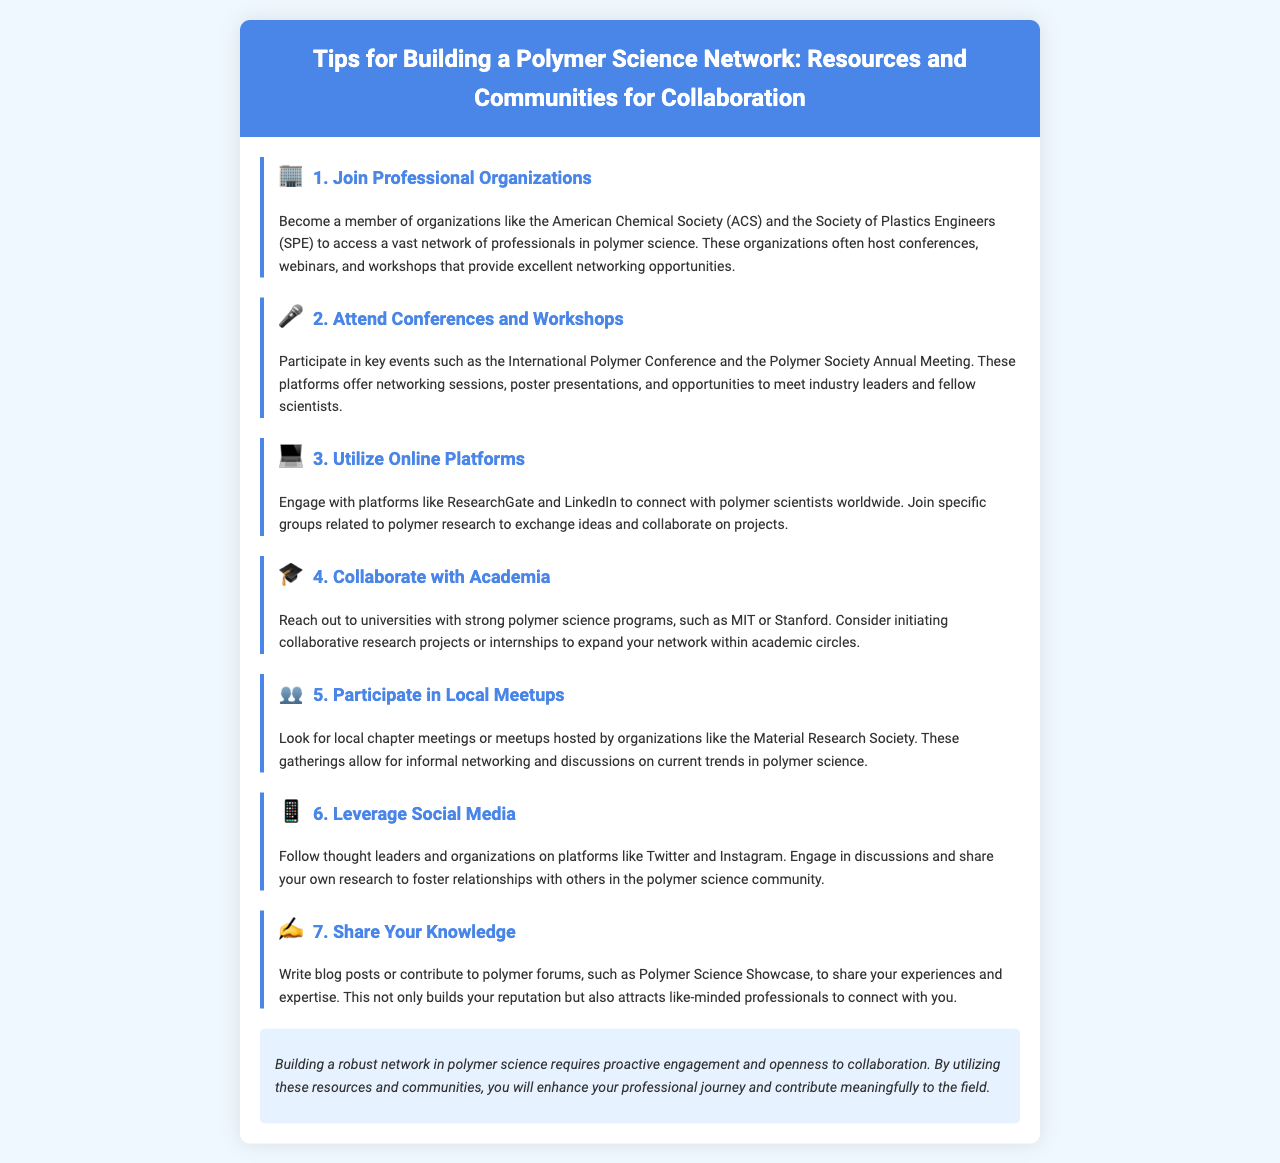What is the title of the brochure? The title is stated at the top of the document, summarizing the focus on networking in polymer science.
Answer: Tips for Building a Polymer Science Network: Resources and Communities for Collaboration Which organization is mentioned for membership? The document lists specific professional organizations that individuals can join for networking opportunities in polymer science.
Answer: American Chemical Society (ACS) How many tips are provided in the brochure? The brochure includes a numbered list of tips to build a polymer science network, which can be counted directly from the sections.
Answer: 7 What type of events are emphasized for networking? The document outlines specific events where networking occurs, indicating the importance of participation in these gatherings.
Answer: Conferences and Workshops Which university is noted for having a strong polymer science program? The brochure suggests reaching out to notable universities known for their polymer science education, naming a specific example.
Answer: MIT What social media platforms are recommended? The document mentions certain platforms where individuals can engage and follow industry leaders, specifying which ones to leverage.
Answer: Twitter and Instagram What should you share to attract like-minded professionals? The brochure advises on content creation as a means to connect with others in the field, indicating a type of output.
Answer: Blog posts 